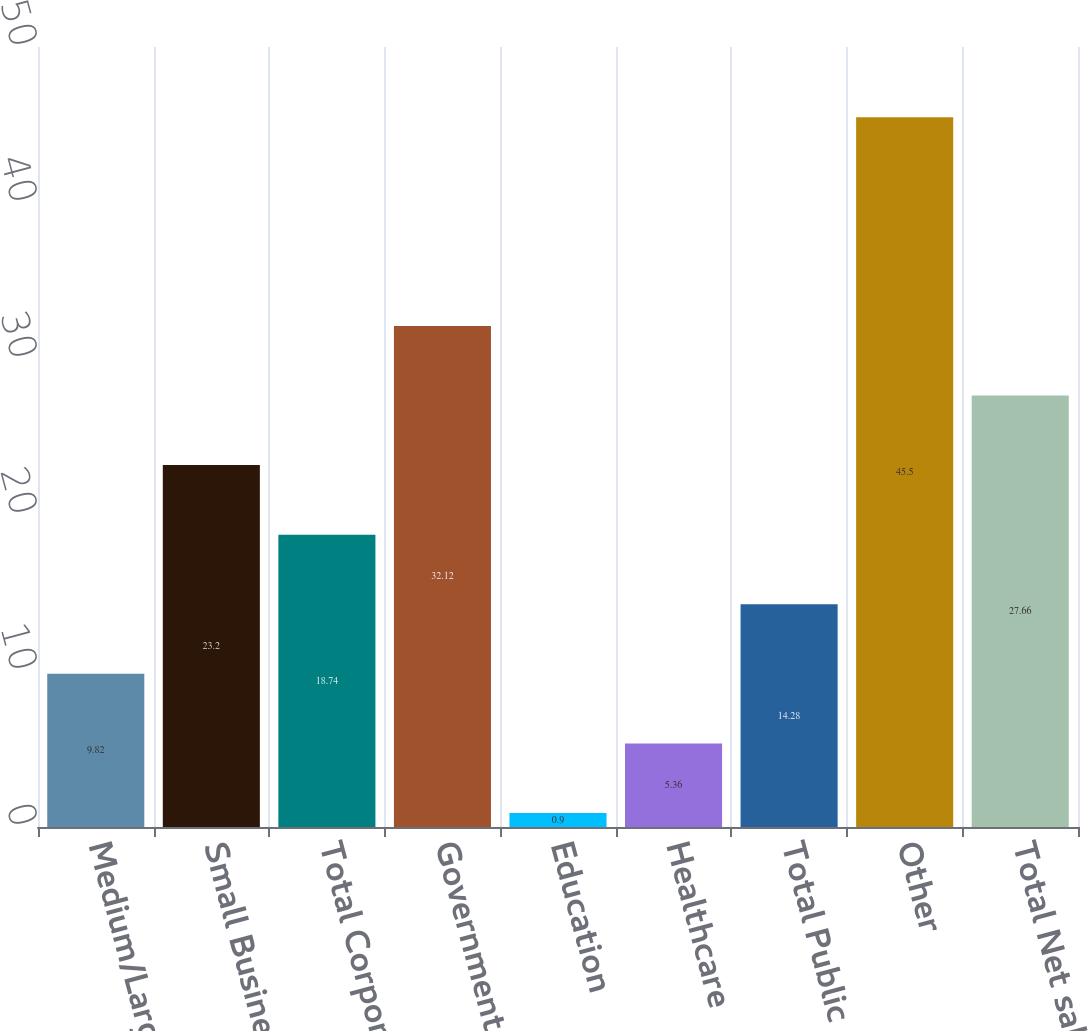Convert chart to OTSL. <chart><loc_0><loc_0><loc_500><loc_500><bar_chart><fcel>Medium/Large<fcel>Small Business<fcel>Total Corporate<fcel>Government<fcel>Education<fcel>Healthcare<fcel>Total Public<fcel>Other<fcel>Total Net sales<nl><fcel>9.82<fcel>23.2<fcel>18.74<fcel>32.12<fcel>0.9<fcel>5.36<fcel>14.28<fcel>45.5<fcel>27.66<nl></chart> 